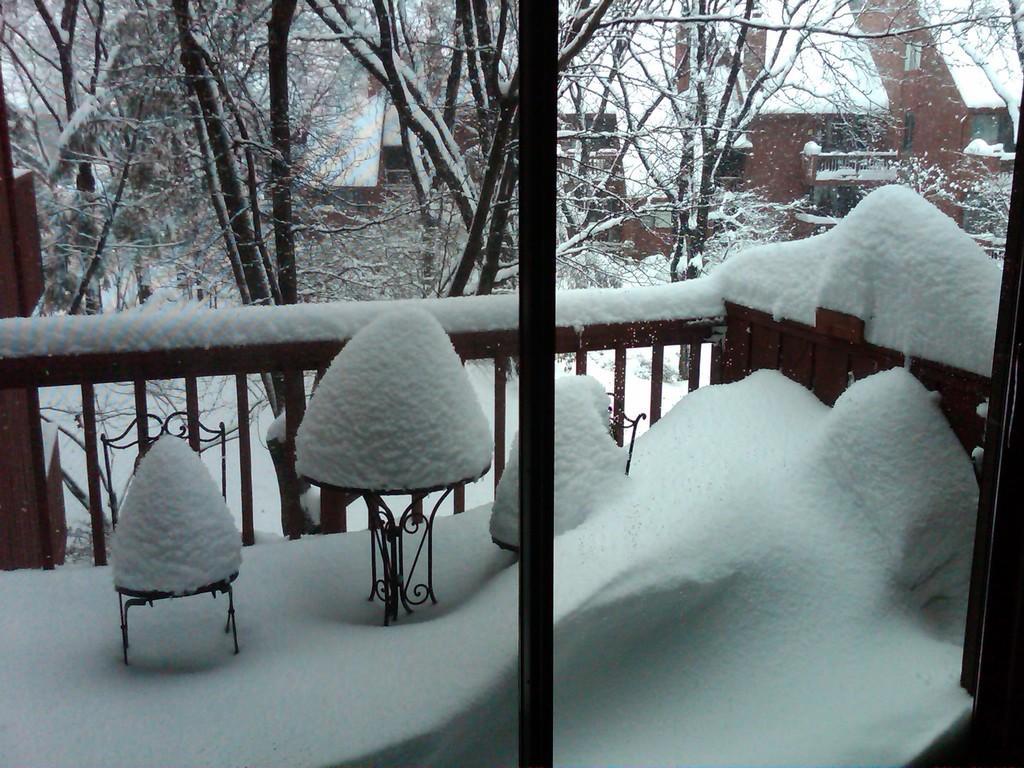What can be seen through the window in the image? Trees, buildings, railings, poles, and stands are visible through the window. How is the weather outside based on the image? The railings, poles, and stands are covered with snow, indicating that it is likely cold and snowy outside. What type of vegetation can be seen through the window? A: Trees are visible through the window. How many sticks are being used as rings for the spiders in the image? There are no sticks, rings, or spiders present in the image. 